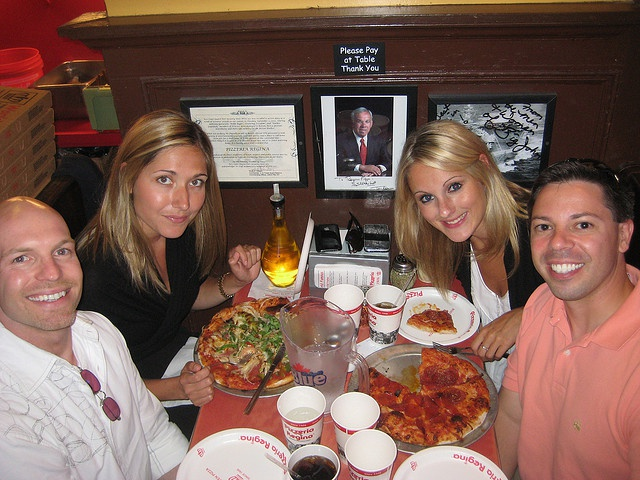Describe the objects in this image and their specific colors. I can see dining table in maroon, lightgray, and brown tones, people in maroon, brown, salmon, and black tones, people in maroon, lightgray, darkgray, salmon, and lightpink tones, people in maroon, black, and gray tones, and people in maroon, gray, black, and brown tones in this image. 